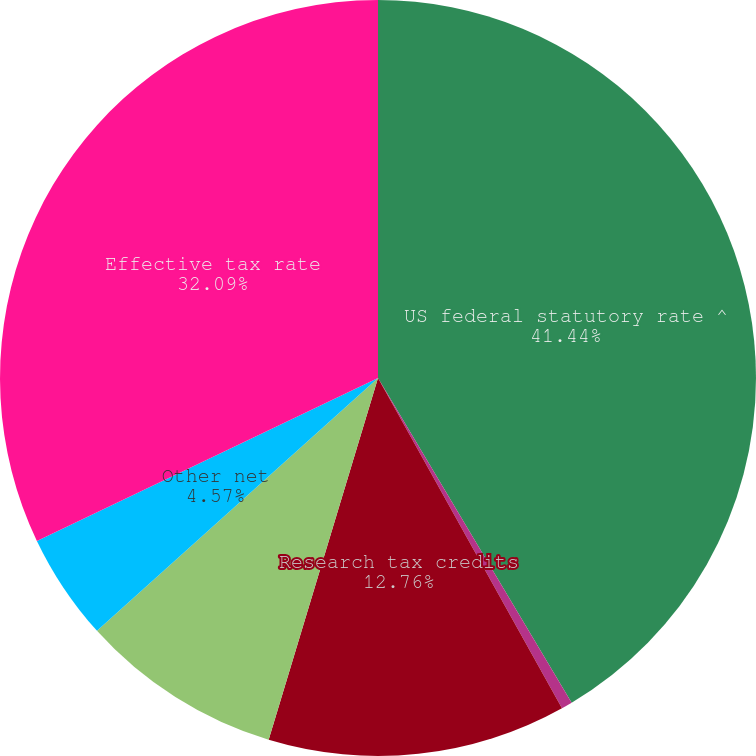<chart> <loc_0><loc_0><loc_500><loc_500><pie_chart><fcel>US federal statutory rate ^<fcel>State income tax net of<fcel>Research tax credits<fcel>Differences in rates and<fcel>Other net<fcel>Effective tax rate<nl><fcel>41.44%<fcel>0.47%<fcel>12.76%<fcel>8.67%<fcel>4.57%<fcel>32.09%<nl></chart> 